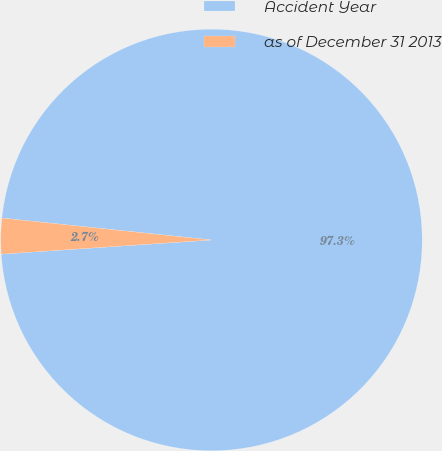<chart> <loc_0><loc_0><loc_500><loc_500><pie_chart><fcel>Accident Year<fcel>as of December 31 2013<nl><fcel>97.27%<fcel>2.73%<nl></chart> 